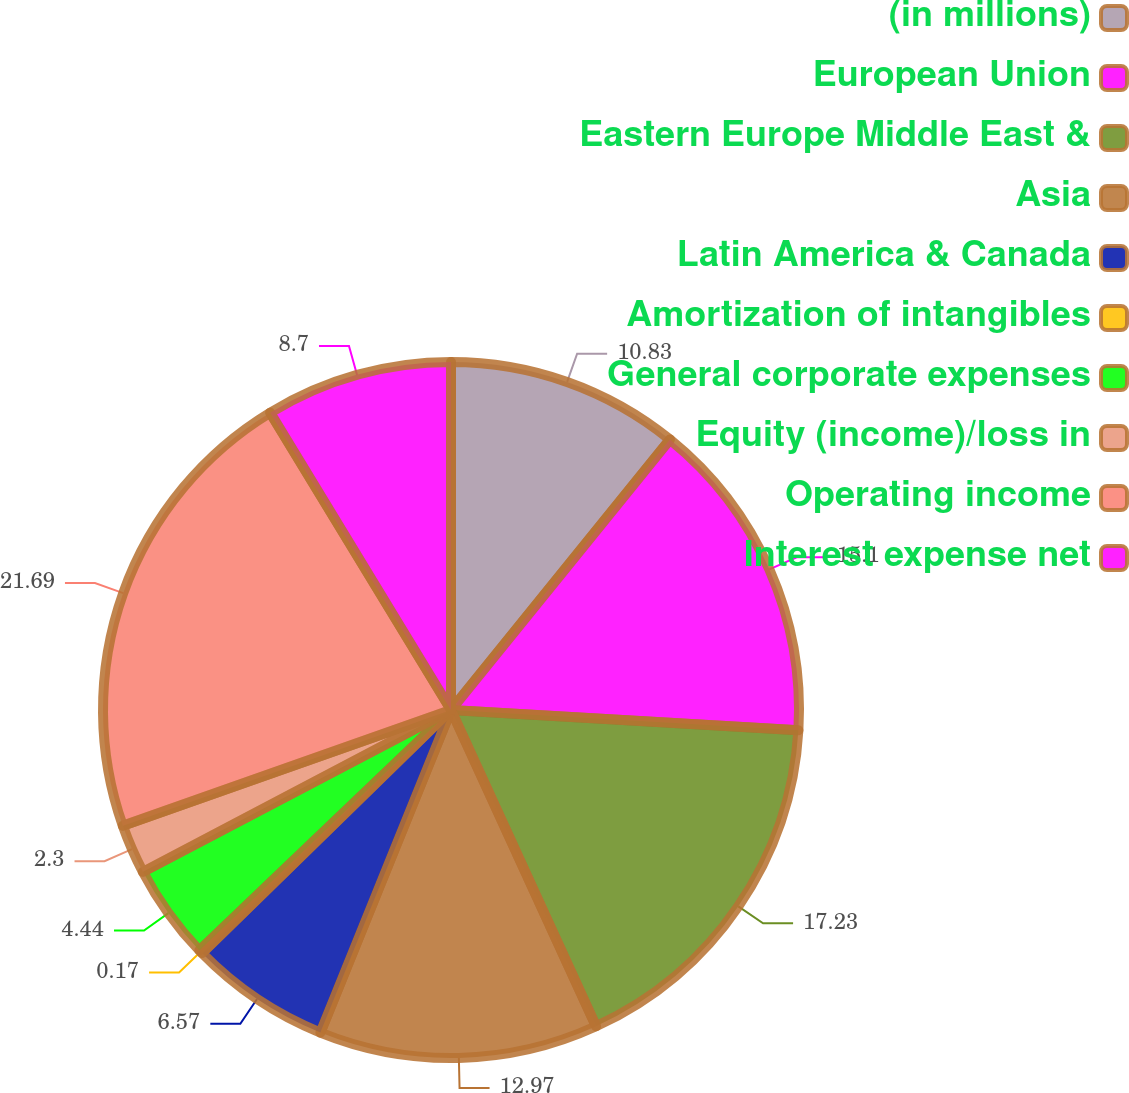<chart> <loc_0><loc_0><loc_500><loc_500><pie_chart><fcel>(in millions)<fcel>European Union<fcel>Eastern Europe Middle East &<fcel>Asia<fcel>Latin America & Canada<fcel>Amortization of intangibles<fcel>General corporate expenses<fcel>Equity (income)/loss in<fcel>Operating income<fcel>Interest expense net<nl><fcel>10.83%<fcel>15.1%<fcel>17.23%<fcel>12.97%<fcel>6.57%<fcel>0.17%<fcel>4.44%<fcel>2.3%<fcel>21.7%<fcel>8.7%<nl></chart> 